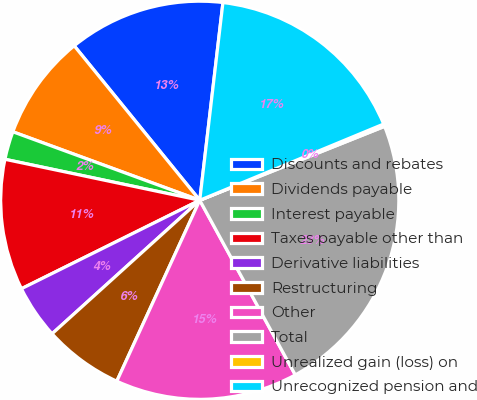Convert chart to OTSL. <chart><loc_0><loc_0><loc_500><loc_500><pie_chart><fcel>Discounts and rebates<fcel>Dividends payable<fcel>Interest payable<fcel>Taxes payable other than<fcel>Derivative liabilities<fcel>Restructuring<fcel>Other<fcel>Total<fcel>Unrealized gain (loss) on<fcel>Unrecognized pension and<nl><fcel>12.72%<fcel>8.55%<fcel>2.29%<fcel>10.63%<fcel>4.37%<fcel>6.46%<fcel>14.81%<fcel>23.09%<fcel>0.2%<fcel>16.89%<nl></chart> 